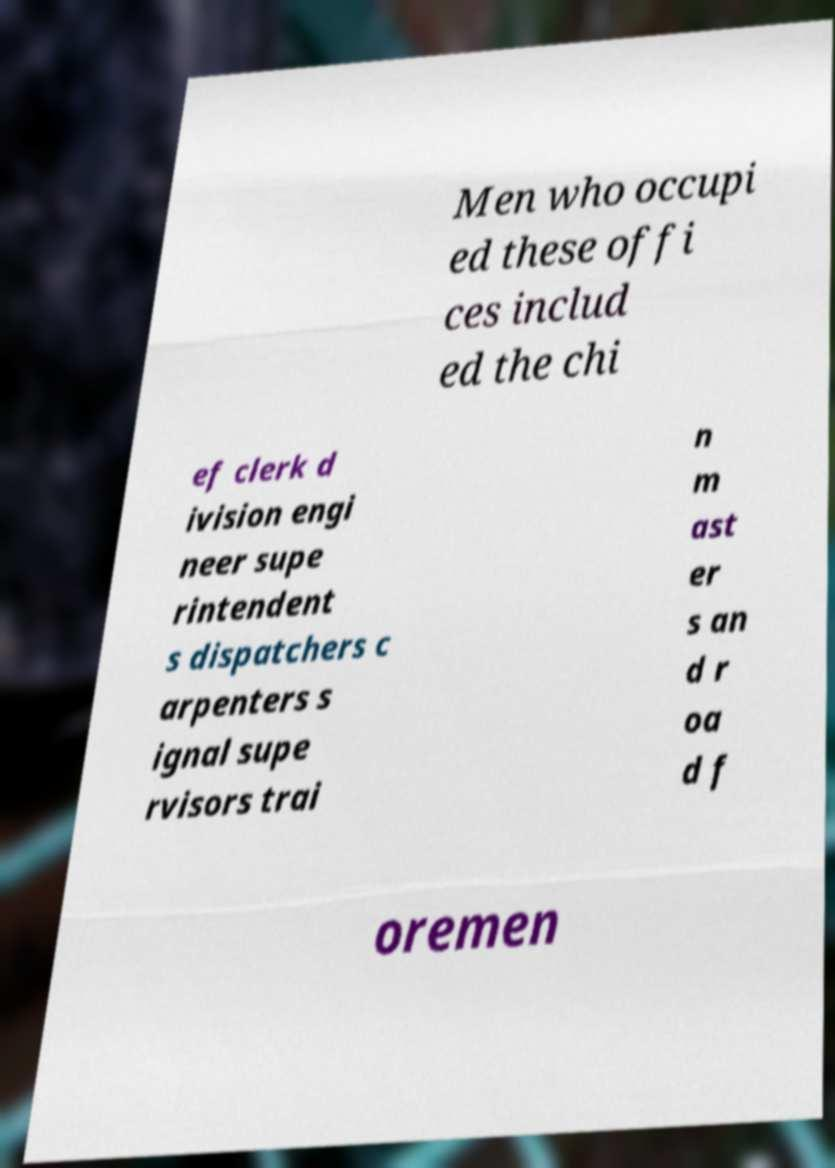Could you extract and type out the text from this image? Men who occupi ed these offi ces includ ed the chi ef clerk d ivision engi neer supe rintendent s dispatchers c arpenters s ignal supe rvisors trai n m ast er s an d r oa d f oremen 